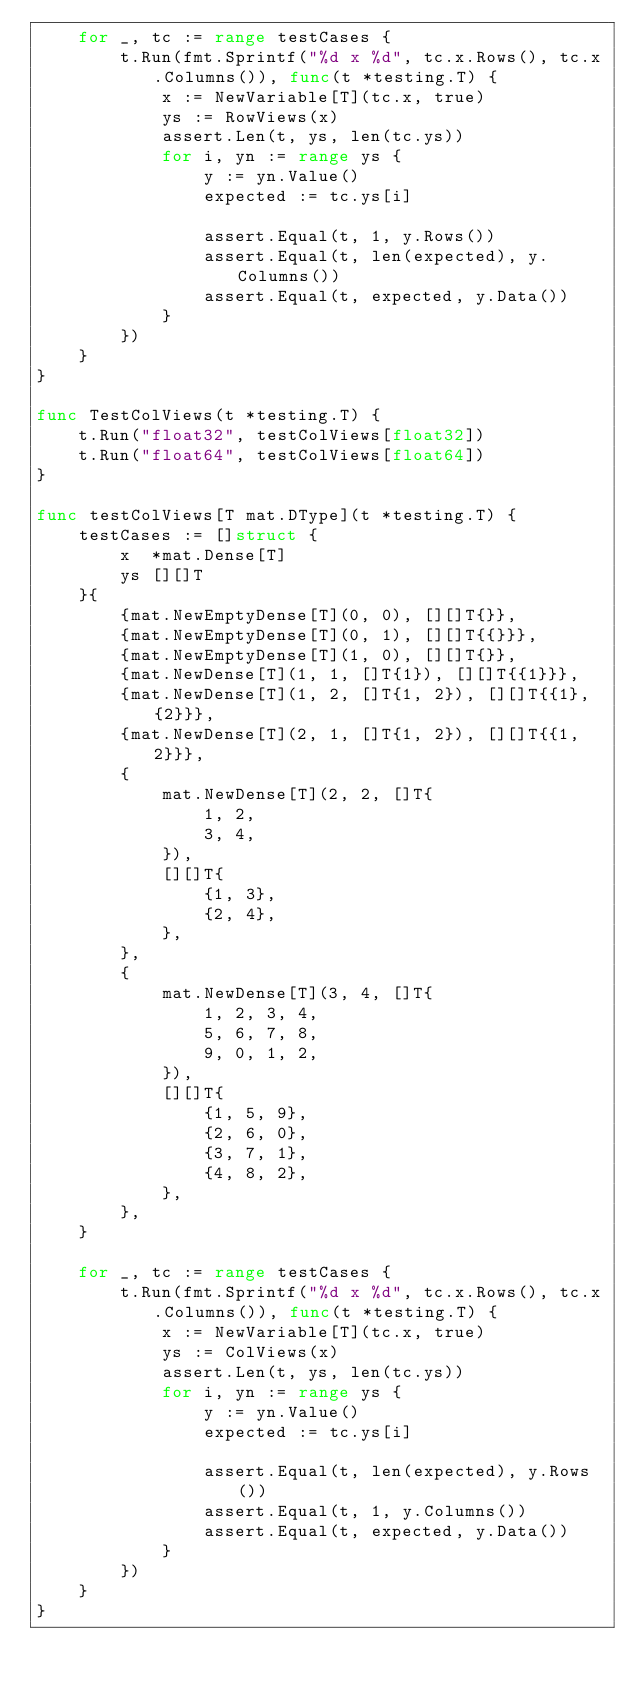Convert code to text. <code><loc_0><loc_0><loc_500><loc_500><_Go_>	for _, tc := range testCases {
		t.Run(fmt.Sprintf("%d x %d", tc.x.Rows(), tc.x.Columns()), func(t *testing.T) {
			x := NewVariable[T](tc.x, true)
			ys := RowViews(x)
			assert.Len(t, ys, len(tc.ys))
			for i, yn := range ys {
				y := yn.Value()
				expected := tc.ys[i]

				assert.Equal(t, 1, y.Rows())
				assert.Equal(t, len(expected), y.Columns())
				assert.Equal(t, expected, y.Data())
			}
		})
	}
}

func TestColViews(t *testing.T) {
	t.Run("float32", testColViews[float32])
	t.Run("float64", testColViews[float64])
}

func testColViews[T mat.DType](t *testing.T) {
	testCases := []struct {
		x  *mat.Dense[T]
		ys [][]T
	}{
		{mat.NewEmptyDense[T](0, 0), [][]T{}},
		{mat.NewEmptyDense[T](0, 1), [][]T{{}}},
		{mat.NewEmptyDense[T](1, 0), [][]T{}},
		{mat.NewDense[T](1, 1, []T{1}), [][]T{{1}}},
		{mat.NewDense[T](1, 2, []T{1, 2}), [][]T{{1}, {2}}},
		{mat.NewDense[T](2, 1, []T{1, 2}), [][]T{{1, 2}}},
		{
			mat.NewDense[T](2, 2, []T{
				1, 2,
				3, 4,
			}),
			[][]T{
				{1, 3},
				{2, 4},
			},
		},
		{
			mat.NewDense[T](3, 4, []T{
				1, 2, 3, 4,
				5, 6, 7, 8,
				9, 0, 1, 2,
			}),
			[][]T{
				{1, 5, 9},
				{2, 6, 0},
				{3, 7, 1},
				{4, 8, 2},
			},
		},
	}

	for _, tc := range testCases {
		t.Run(fmt.Sprintf("%d x %d", tc.x.Rows(), tc.x.Columns()), func(t *testing.T) {
			x := NewVariable[T](tc.x, true)
			ys := ColViews(x)
			assert.Len(t, ys, len(tc.ys))
			for i, yn := range ys {
				y := yn.Value()
				expected := tc.ys[i]

				assert.Equal(t, len(expected), y.Rows())
				assert.Equal(t, 1, y.Columns())
				assert.Equal(t, expected, y.Data())
			}
		})
	}
}
</code> 